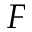Convert formula to latex. <formula><loc_0><loc_0><loc_500><loc_500>F</formula> 